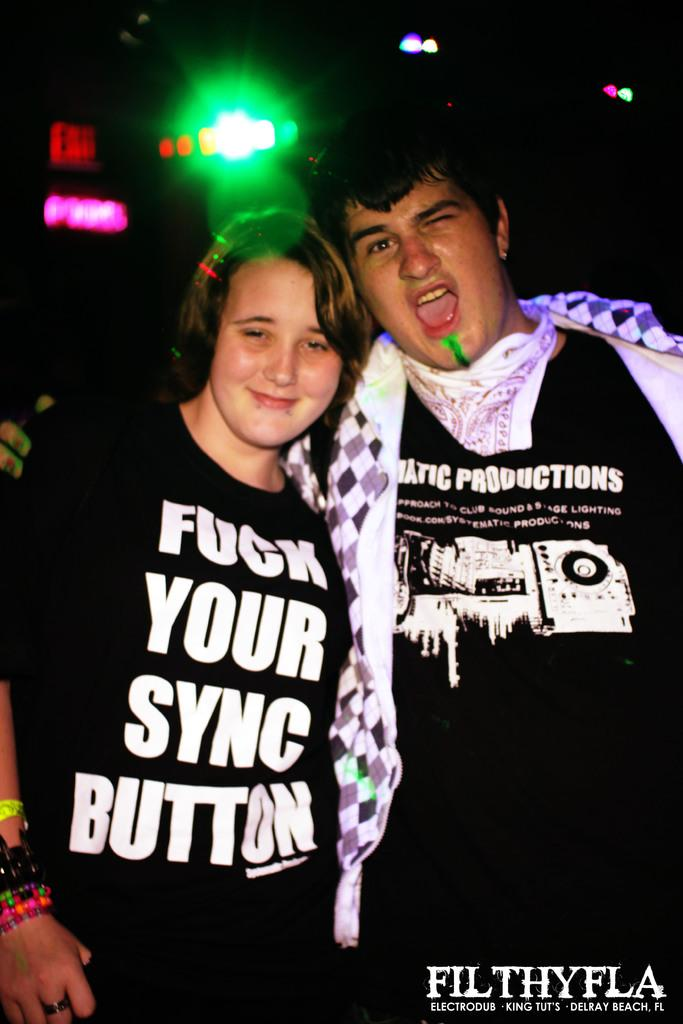How many people are in the image? There are two persons in the image. What color are the dresses worn by the persons in the image? Both persons are wearing black color dresses. Is there any text visible in the image? Yes, there is text in the bottom right corner of the image. What can be seen in the background of the image? There is a light in the background of the image. What type of noise can be heard coming from the brake in the image? There is no brake present in the image, so it's not possible to determine what, if any, noise might be heard. Is there any thunder visible in the image? There is no thunder present in the image; it features two persons wearing black dresses, text in the bottom right corner, and a light in the background. 